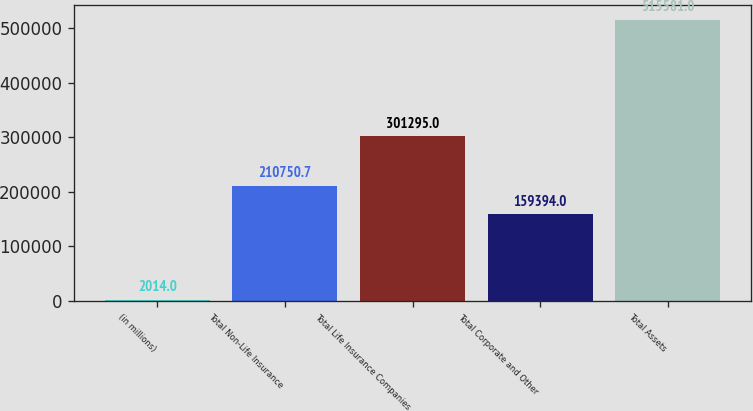Convert chart. <chart><loc_0><loc_0><loc_500><loc_500><bar_chart><fcel>(in millions)<fcel>Total Non-Life Insurance<fcel>Total Life Insurance Companies<fcel>Total Corporate and Other<fcel>Total Assets<nl><fcel>2014<fcel>210751<fcel>301295<fcel>159394<fcel>515581<nl></chart> 